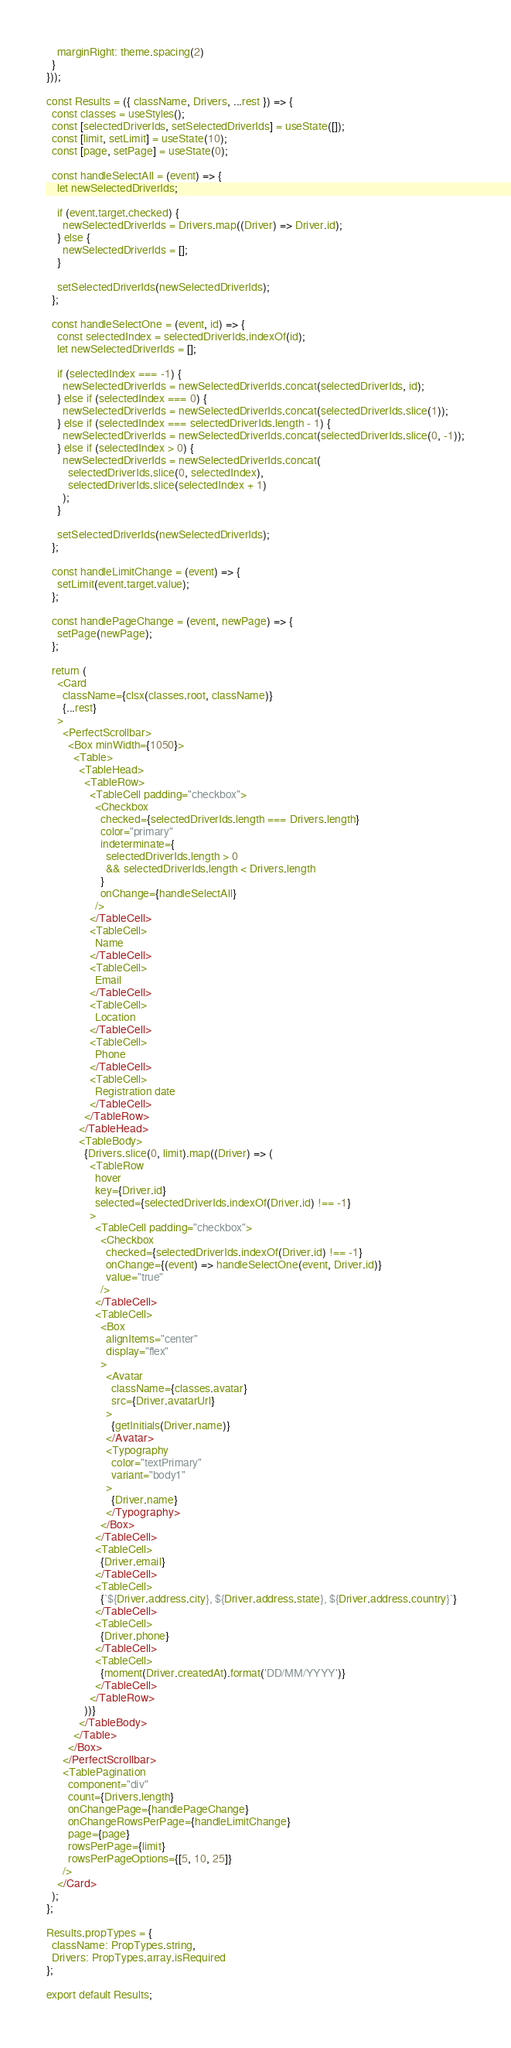<code> <loc_0><loc_0><loc_500><loc_500><_JavaScript_>    marginRight: theme.spacing(2)
  }
}));

const Results = ({ className, Drivers, ...rest }) => {
  const classes = useStyles();
  const [selectedDriverIds, setSelectedDriverIds] = useState([]);
  const [limit, setLimit] = useState(10);
  const [page, setPage] = useState(0);

  const handleSelectAll = (event) => {
    let newSelectedDriverIds;

    if (event.target.checked) {
      newSelectedDriverIds = Drivers.map((Driver) => Driver.id);
    } else {
      newSelectedDriverIds = [];
    }

    setSelectedDriverIds(newSelectedDriverIds);
  };

  const handleSelectOne = (event, id) => {
    const selectedIndex = selectedDriverIds.indexOf(id);
    let newSelectedDriverIds = [];

    if (selectedIndex === -1) {
      newSelectedDriverIds = newSelectedDriverIds.concat(selectedDriverIds, id);
    } else if (selectedIndex === 0) {
      newSelectedDriverIds = newSelectedDriverIds.concat(selectedDriverIds.slice(1));
    } else if (selectedIndex === selectedDriverIds.length - 1) {
      newSelectedDriverIds = newSelectedDriverIds.concat(selectedDriverIds.slice(0, -1));
    } else if (selectedIndex > 0) {
      newSelectedDriverIds = newSelectedDriverIds.concat(
        selectedDriverIds.slice(0, selectedIndex),
        selectedDriverIds.slice(selectedIndex + 1)
      );
    }

    setSelectedDriverIds(newSelectedDriverIds);
  };

  const handleLimitChange = (event) => {
    setLimit(event.target.value);
  };

  const handlePageChange = (event, newPage) => {
    setPage(newPage);
  };

  return (
    <Card
      className={clsx(classes.root, className)}
      {...rest}
    >
      <PerfectScrollbar>
        <Box minWidth={1050}>
          <Table>
            <TableHead>
              <TableRow>
                <TableCell padding="checkbox">
                  <Checkbox
                    checked={selectedDriverIds.length === Drivers.length}
                    color="primary"
                    indeterminate={
                      selectedDriverIds.length > 0
                      && selectedDriverIds.length < Drivers.length
                    }
                    onChange={handleSelectAll}
                  />
                </TableCell>
                <TableCell>
                  Name
                </TableCell>
                <TableCell>
                  Email
                </TableCell>
                <TableCell>
                  Location
                </TableCell>
                <TableCell>
                  Phone
                </TableCell>
                <TableCell>
                  Registration date
                </TableCell>
              </TableRow>
            </TableHead>
            <TableBody>
              {Drivers.slice(0, limit).map((Driver) => (
                <TableRow
                  hover
                  key={Driver.id}
                  selected={selectedDriverIds.indexOf(Driver.id) !== -1}
                >
                  <TableCell padding="checkbox">
                    <Checkbox
                      checked={selectedDriverIds.indexOf(Driver.id) !== -1}
                      onChange={(event) => handleSelectOne(event, Driver.id)}
                      value="true"
                    />
                  </TableCell>
                  <TableCell>
                    <Box
                      alignItems="center"
                      display="flex"
                    >
                      <Avatar
                        className={classes.avatar}
                        src={Driver.avatarUrl}
                      >
                        {getInitials(Driver.name)}
                      </Avatar>
                      <Typography
                        color="textPrimary"
                        variant="body1"
                      >
                        {Driver.name}
                      </Typography>
                    </Box>
                  </TableCell>
                  <TableCell>
                    {Driver.email}
                  </TableCell>
                  <TableCell>
                    {`${Driver.address.city}, ${Driver.address.state}, ${Driver.address.country}`}
                  </TableCell>
                  <TableCell>
                    {Driver.phone}
                  </TableCell>
                  <TableCell>
                    {moment(Driver.createdAt).format('DD/MM/YYYY')}
                  </TableCell>
                </TableRow>
              ))}
            </TableBody>
          </Table>
        </Box>
      </PerfectScrollbar>
      <TablePagination
        component="div"
        count={Drivers.length}
        onChangePage={handlePageChange}
        onChangeRowsPerPage={handleLimitChange}
        page={page}
        rowsPerPage={limit}
        rowsPerPageOptions={[5, 10, 25]}
      />
    </Card>
  );
};

Results.propTypes = {
  className: PropTypes.string,
  Drivers: PropTypes.array.isRequired
};

export default Results;
</code> 